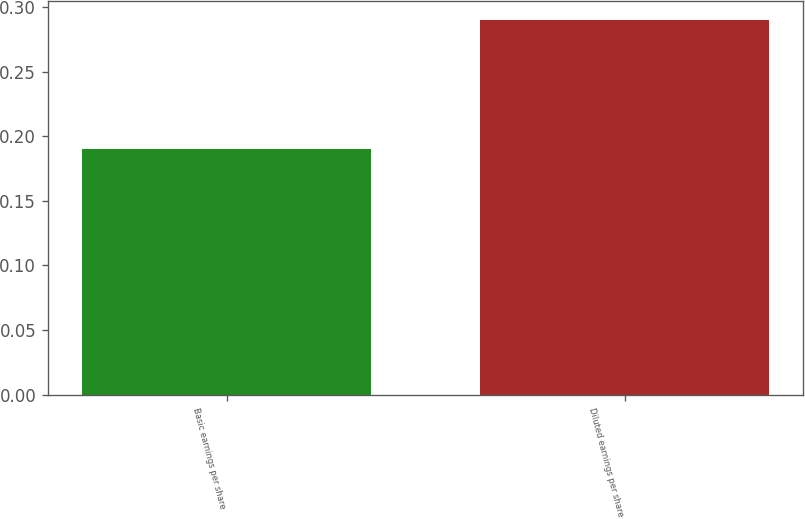Convert chart to OTSL. <chart><loc_0><loc_0><loc_500><loc_500><bar_chart><fcel>Basic earnings per share<fcel>Diluted earnings per share<nl><fcel>0.19<fcel>0.29<nl></chart> 